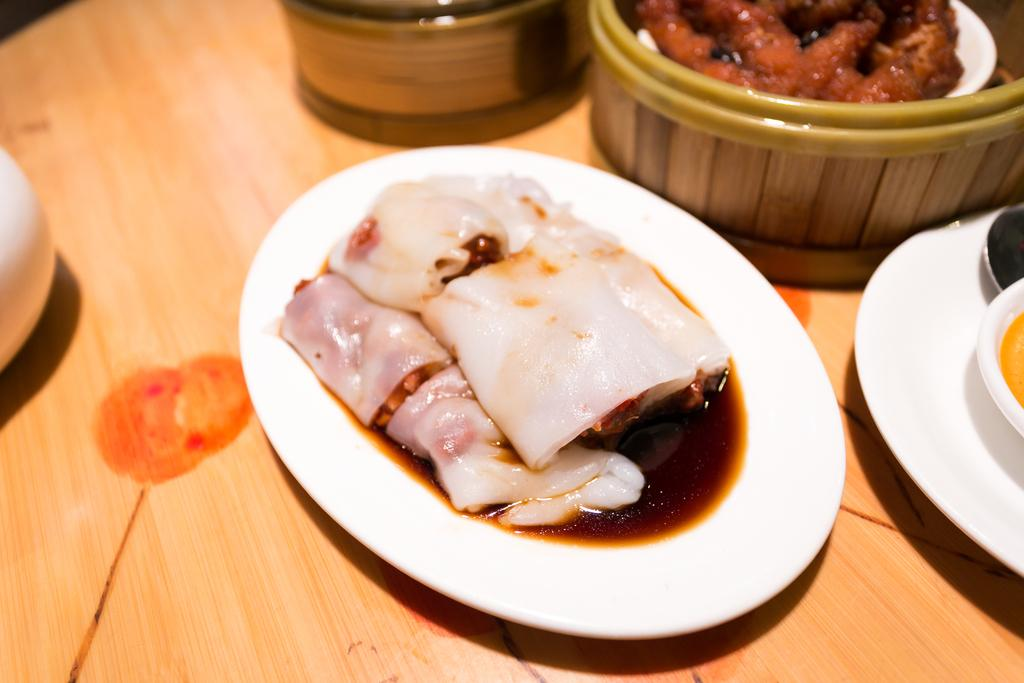What type of furniture is present in the image? There is a table in the image. What objects are placed on the table? There are plates and bowls on the table. What can be found inside the plates and bowls? There are various food items in the plates and bowls. What type of metal is used to construct the view in the image? There is no mention of a view or any metal construction in the image. The image primarily features a table with plates and bowls containing food items. 